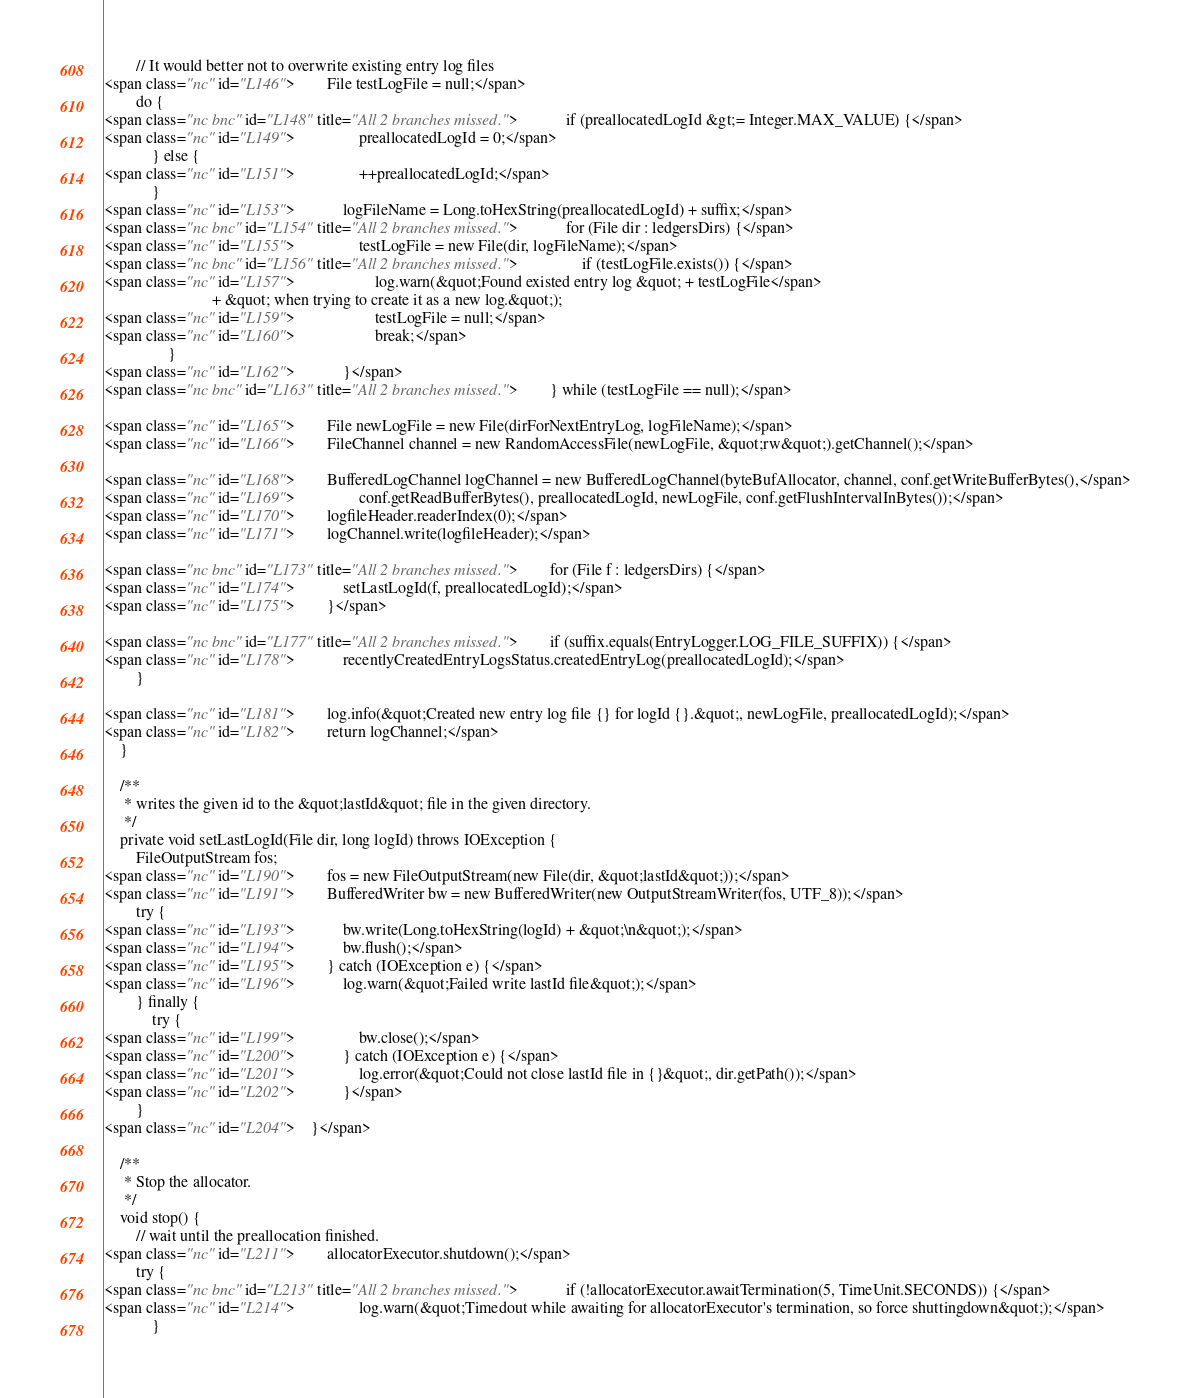<code> <loc_0><loc_0><loc_500><loc_500><_HTML_>        // It would better not to overwrite existing entry log files
<span class="nc" id="L146">        File testLogFile = null;</span>
        do {
<span class="nc bnc" id="L148" title="All 2 branches missed.">            if (preallocatedLogId &gt;= Integer.MAX_VALUE) {</span>
<span class="nc" id="L149">                preallocatedLogId = 0;</span>
            } else {
<span class="nc" id="L151">                ++preallocatedLogId;</span>
            }
<span class="nc" id="L153">            logFileName = Long.toHexString(preallocatedLogId) + suffix;</span>
<span class="nc bnc" id="L154" title="All 2 branches missed.">            for (File dir : ledgersDirs) {</span>
<span class="nc" id="L155">                testLogFile = new File(dir, logFileName);</span>
<span class="nc bnc" id="L156" title="All 2 branches missed.">                if (testLogFile.exists()) {</span>
<span class="nc" id="L157">                    log.warn(&quot;Found existed entry log &quot; + testLogFile</span>
                           + &quot; when trying to create it as a new log.&quot;);
<span class="nc" id="L159">                    testLogFile = null;</span>
<span class="nc" id="L160">                    break;</span>
                }
<span class="nc" id="L162">            }</span>
<span class="nc bnc" id="L163" title="All 2 branches missed.">        } while (testLogFile == null);</span>

<span class="nc" id="L165">        File newLogFile = new File(dirForNextEntryLog, logFileName);</span>
<span class="nc" id="L166">        FileChannel channel = new RandomAccessFile(newLogFile, &quot;rw&quot;).getChannel();</span>

<span class="nc" id="L168">        BufferedLogChannel logChannel = new BufferedLogChannel(byteBufAllocator, channel, conf.getWriteBufferBytes(),</span>
<span class="nc" id="L169">                conf.getReadBufferBytes(), preallocatedLogId, newLogFile, conf.getFlushIntervalInBytes());</span>
<span class="nc" id="L170">        logfileHeader.readerIndex(0);</span>
<span class="nc" id="L171">        logChannel.write(logfileHeader);</span>

<span class="nc bnc" id="L173" title="All 2 branches missed.">        for (File f : ledgersDirs) {</span>
<span class="nc" id="L174">            setLastLogId(f, preallocatedLogId);</span>
<span class="nc" id="L175">        }</span>

<span class="nc bnc" id="L177" title="All 2 branches missed.">        if (suffix.equals(EntryLogger.LOG_FILE_SUFFIX)) {</span>
<span class="nc" id="L178">            recentlyCreatedEntryLogsStatus.createdEntryLog(preallocatedLogId);</span>
        }

<span class="nc" id="L181">        log.info(&quot;Created new entry log file {} for logId {}.&quot;, newLogFile, preallocatedLogId);</span>
<span class="nc" id="L182">        return logChannel;</span>
    }

    /**
     * writes the given id to the &quot;lastId&quot; file in the given directory.
     */
    private void setLastLogId(File dir, long logId) throws IOException {
        FileOutputStream fos;
<span class="nc" id="L190">        fos = new FileOutputStream(new File(dir, &quot;lastId&quot;));</span>
<span class="nc" id="L191">        BufferedWriter bw = new BufferedWriter(new OutputStreamWriter(fos, UTF_8));</span>
        try {
<span class="nc" id="L193">            bw.write(Long.toHexString(logId) + &quot;\n&quot;);</span>
<span class="nc" id="L194">            bw.flush();</span>
<span class="nc" id="L195">        } catch (IOException e) {</span>
<span class="nc" id="L196">            log.warn(&quot;Failed write lastId file&quot;);</span>
        } finally {
            try {
<span class="nc" id="L199">                bw.close();</span>
<span class="nc" id="L200">            } catch (IOException e) {</span>
<span class="nc" id="L201">                log.error(&quot;Could not close lastId file in {}&quot;, dir.getPath());</span>
<span class="nc" id="L202">            }</span>
        }
<span class="nc" id="L204">    }</span>

    /**
     * Stop the allocator.
     */
    void stop() {
        // wait until the preallocation finished.
<span class="nc" id="L211">        allocatorExecutor.shutdown();</span>
        try {
<span class="nc bnc" id="L213" title="All 2 branches missed.">            if (!allocatorExecutor.awaitTermination(5, TimeUnit.SECONDS)) {</span>
<span class="nc" id="L214">                log.warn(&quot;Timedout while awaiting for allocatorExecutor's termination, so force shuttingdown&quot;);</span>
            }</code> 